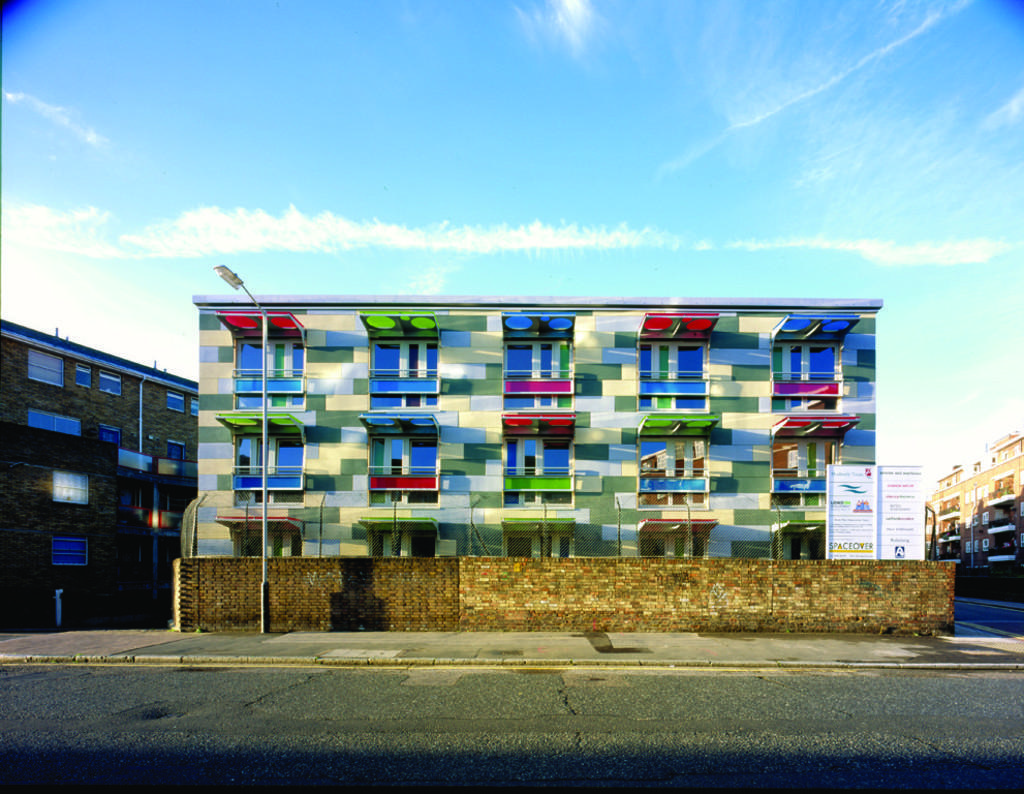How would you summarize this image in a sentence or two? In this picture there is a building in the center of the image and there are other buildings on the right and left side of the image. 